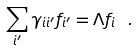Convert formula to latex. <formula><loc_0><loc_0><loc_500><loc_500>\sum _ { i ^ { \prime } } \gamma _ { i i ^ { \prime } } f _ { i ^ { \prime } } = \Lambda f _ { i } \ .</formula> 